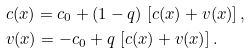Convert formula to latex. <formula><loc_0><loc_0><loc_500><loc_500>& c ( x ) = c _ { 0 } + ( 1 - q ) \, \left [ c ( x ) + v ( x ) \right ] , \\ & v ( x ) = - c _ { 0 } + q \, \left [ c ( x ) + v ( x ) \right ] .</formula> 